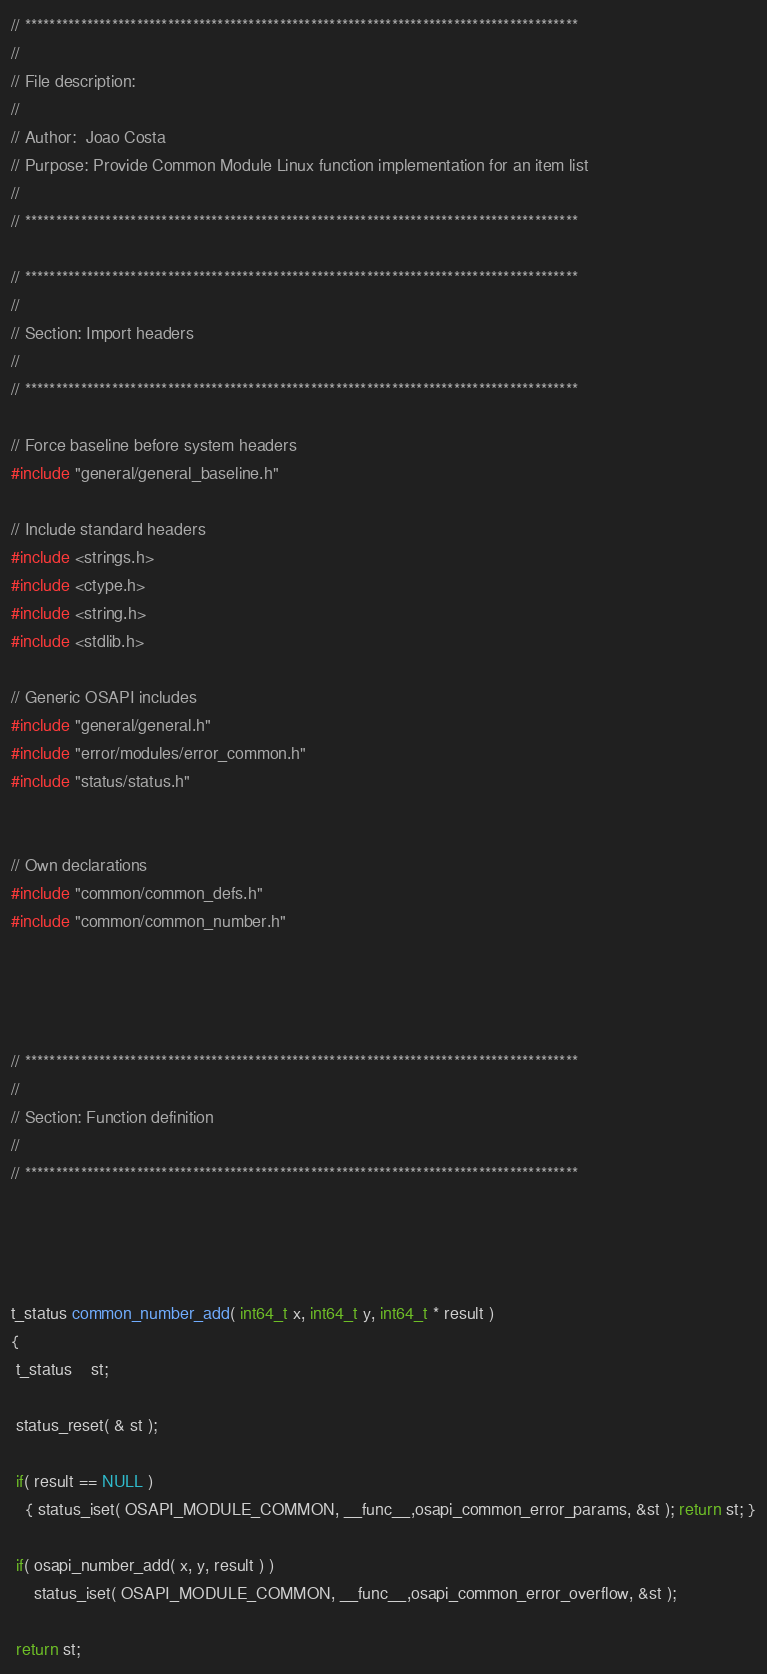<code> <loc_0><loc_0><loc_500><loc_500><_C_>// *****************************************************************************************
//
// File description:
//
// Author:	Joao Costa
// Purpose:	Provide Common Module Linux function implementation for an item list
//
// *****************************************************************************************

// *****************************************************************************************
//
// Section: Import headers
//
// *****************************************************************************************

// Force baseline before system headers
#include "general/general_baseline.h"

// Include standard headers
#include <strings.h>
#include <ctype.h>
#include <string.h>
#include <stdlib.h>

// Generic OSAPI includes
#include "general/general.h"
#include "error/modules/error_common.h"
#include "status/status.h"


// Own declarations
#include "common/common_defs.h"
#include "common/common_number.h"




// *****************************************************************************************
//
// Section: Function definition
//
// *****************************************************************************************




t_status common_number_add( int64_t x, int64_t y, int64_t * result )
{
 t_status	st;

 status_reset( & st );

 if( result == NULL )
   { status_iset( OSAPI_MODULE_COMMON, __func__,osapi_common_error_params, &st ); return st; }

 if( osapi_number_add( x, y, result ) )
     status_iset( OSAPI_MODULE_COMMON, __func__,osapi_common_error_overflow, &st );

 return st;</code> 